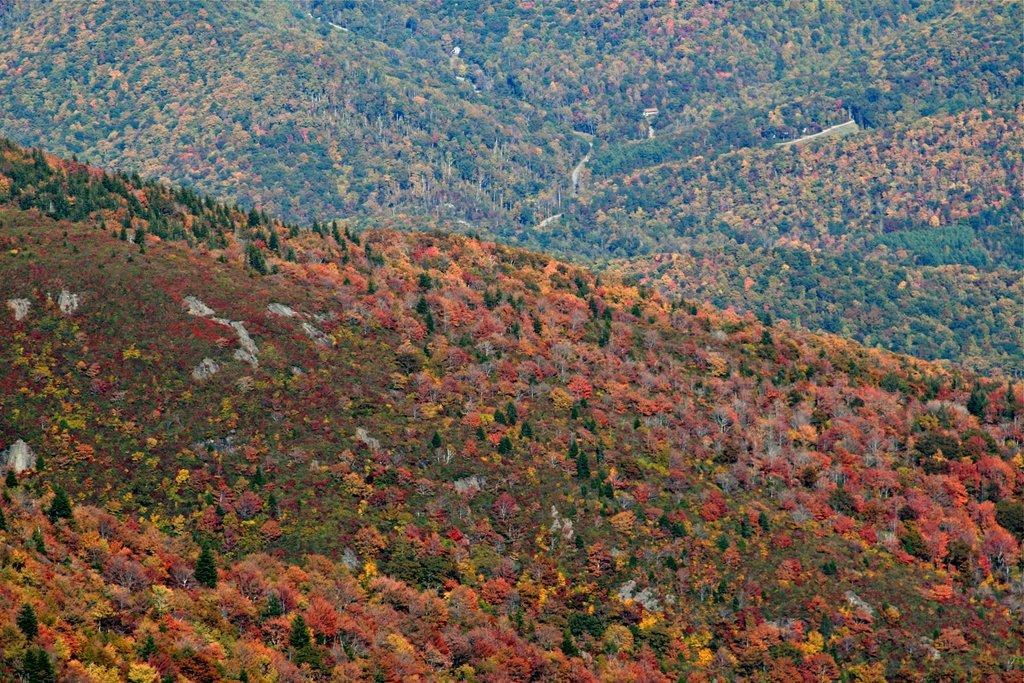What type of natural formation can be seen in the image? There are mountains in the image. Are there any plants visible on the mountains? Yes, trees are present on the mountains in the image. What type of brass instrument can be seen in the image? There is no brass instrument present in the image; it features mountains with trees. What type of vegetable is growing on the mountains in the image? There are no vegetables visible in the image; only trees are present on the mountains. 